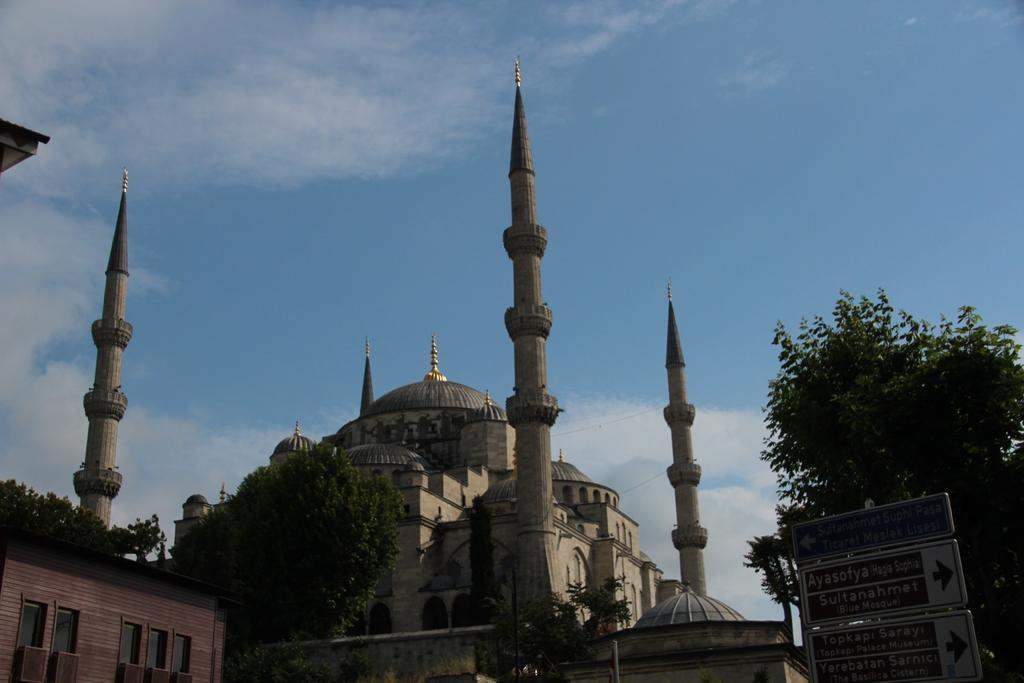What type of structure is in the image? There is a fort in the image. What other natural elements can be seen in the image? There are trees in the image. Are there any residential structures in the image? Yes, there is a house in the image. Where are the sign boards located in the image? The sign boards are present on the right side bottom of the image. What is visible in the background of the image? The sky is visible in the background of the image. Can you see a basketball being played in the image? There is no basketball or any indication of a game being played in the image. Is there a hand holding a chain in the image? There is no hand or chain present in the image. 